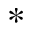Convert formula to latex. <formula><loc_0><loc_0><loc_500><loc_500>^ { * }</formula> 